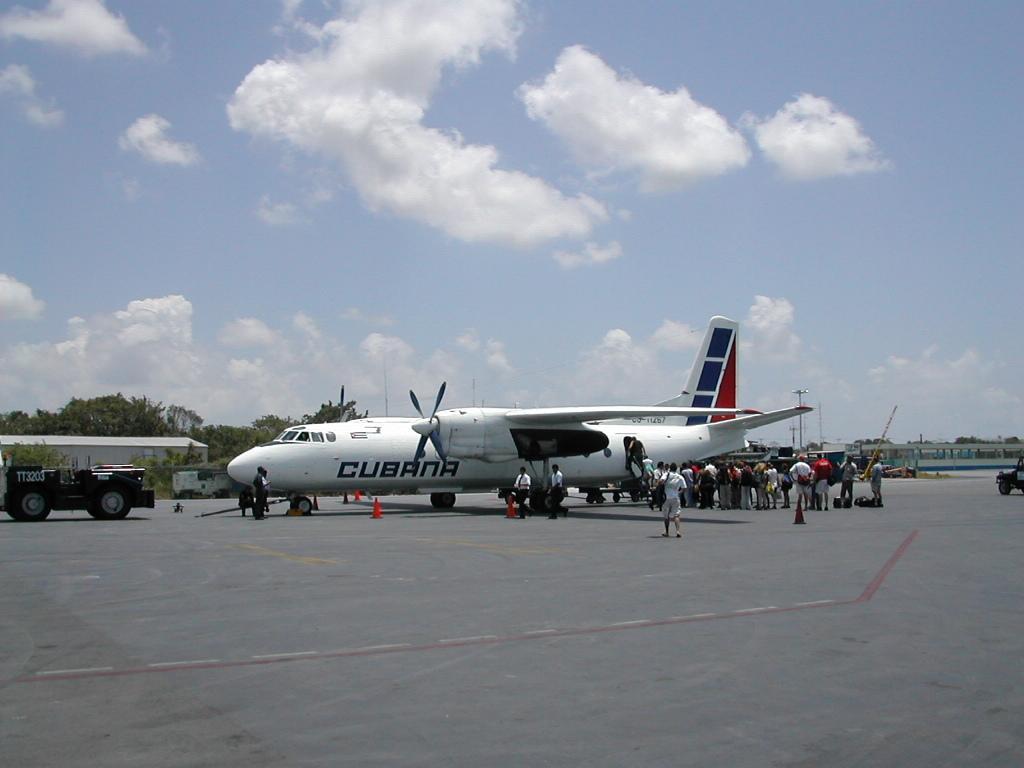Could you give a brief overview of what you see in this image? The picture is taken in an airport. In the center of the picture there is an airplane and there are are people. On the left there is a vehicle. In the background there are buildings and trees. In the foreground it is runway. 